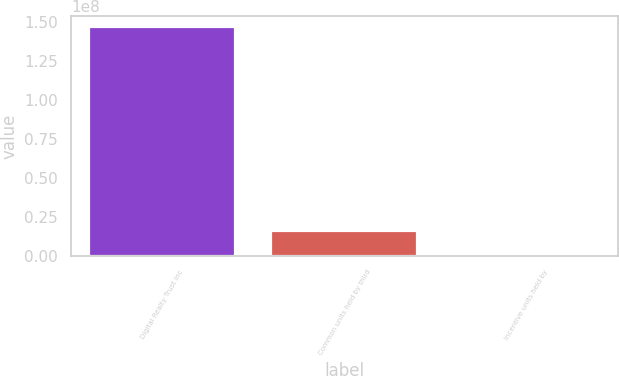Convert chart. <chart><loc_0><loc_0><loc_500><loc_500><bar_chart><fcel>Digital Realty Trust Inc<fcel>Common units held by third<fcel>Incentive units held by<nl><fcel>1.46384e+08<fcel>1.59092e+07<fcel>1.41201e+06<nl></chart> 